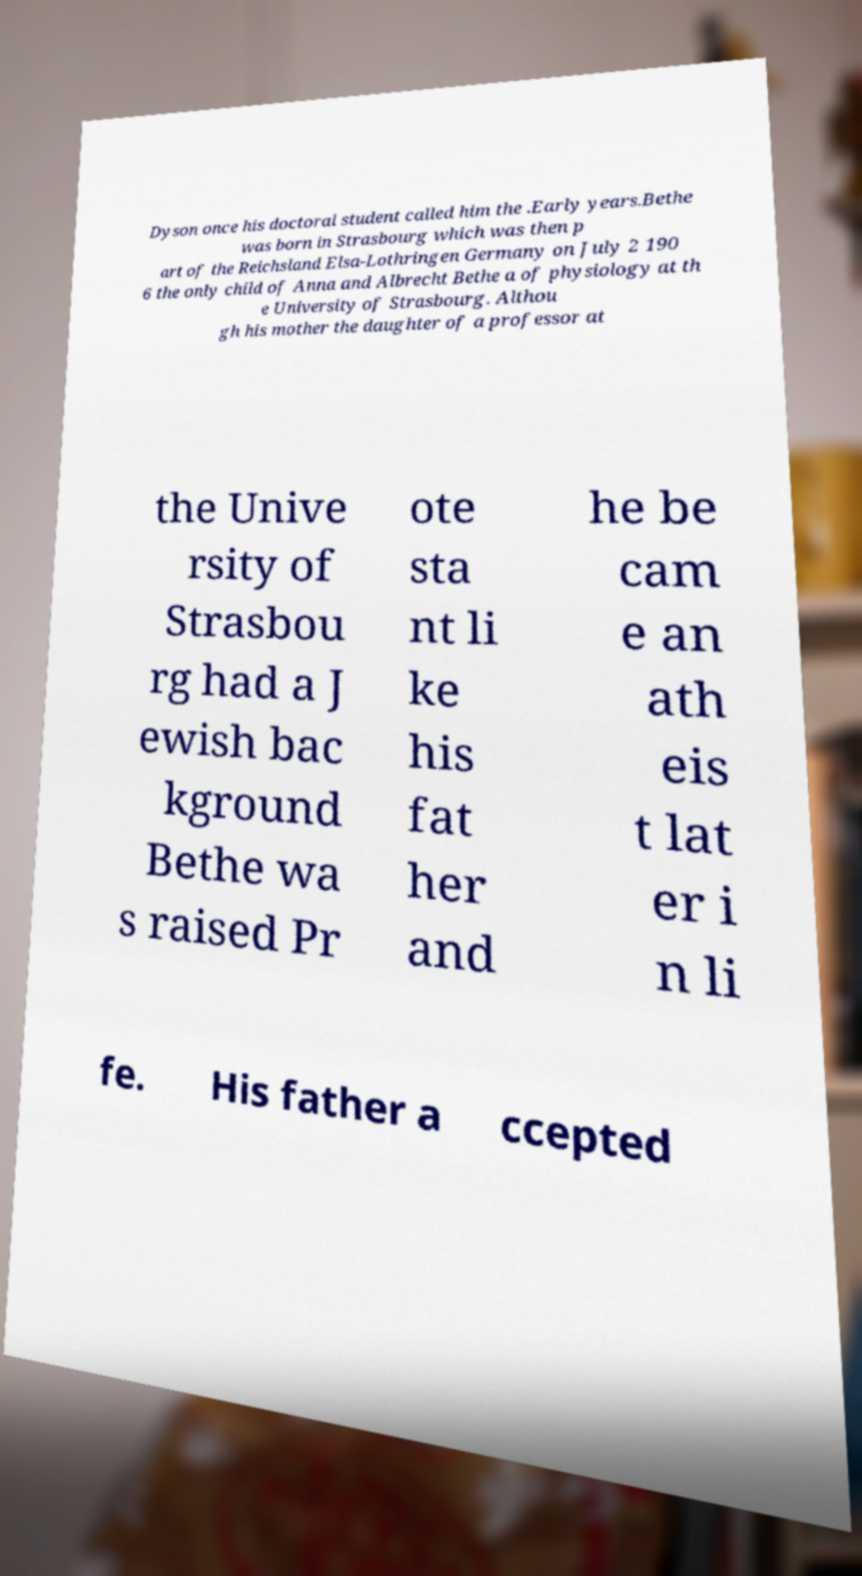Could you assist in decoding the text presented in this image and type it out clearly? Dyson once his doctoral student called him the .Early years.Bethe was born in Strasbourg which was then p art of the Reichsland Elsa-Lothringen Germany on July 2 190 6 the only child of Anna and Albrecht Bethe a of physiology at th e University of Strasbourg. Althou gh his mother the daughter of a professor at the Unive rsity of Strasbou rg had a J ewish bac kground Bethe wa s raised Pr ote sta nt li ke his fat her and he be cam e an ath eis t lat er i n li fe. His father a ccepted 